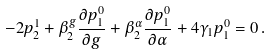<formula> <loc_0><loc_0><loc_500><loc_500>- 2 p ^ { 1 } _ { 2 } + \beta ^ { g } _ { 2 } \frac { \partial p ^ { 0 } _ { 1 } } { \partial g } + \beta ^ { \alpha } _ { 2 } \frac { \partial p ^ { 0 } _ { 1 } } { \partial \alpha } + 4 \gamma _ { 1 } p ^ { 0 } _ { 1 } = 0 \, .</formula> 